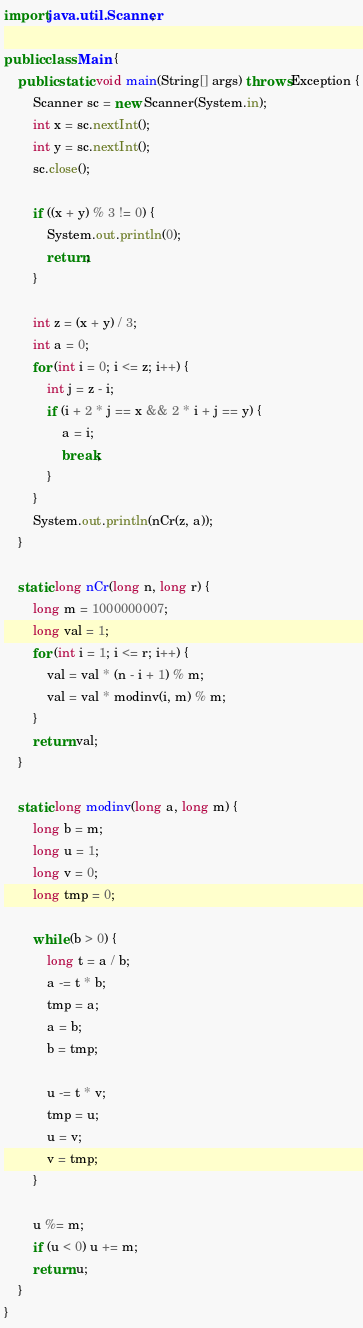<code> <loc_0><loc_0><loc_500><loc_500><_Java_>import java.util.Scanner;

public class Main {
	public static void main(String[] args) throws Exception {
		Scanner sc = new Scanner(System.in);
		int x = sc.nextInt();
		int y = sc.nextInt();
		sc.close();

		if ((x + y) % 3 != 0) {
			System.out.println(0);
			return;
		}

		int z = (x + y) / 3;
		int a = 0;
		for (int i = 0; i <= z; i++) {
			int j = z - i;
			if (i + 2 * j == x && 2 * i + j == y) {
				a = i;
				break;
			}
		}
		System.out.println(nCr(z, a));
	}

	static long nCr(long n, long r) {
		long m = 1000000007;
		long val = 1;
		for (int i = 1; i <= r; i++) {
			val = val * (n - i + 1) % m;
			val = val * modinv(i, m) % m;
		}
		return val;
	}

	static long modinv(long a, long m) {
		long b = m;
		long u = 1;
		long v = 0;
		long tmp = 0;

		while (b > 0) {
			long t = a / b;
			a -= t * b;
			tmp = a;
			a = b;
			b = tmp;

			u -= t * v;
			tmp = u;
			u = v;
			v = tmp;
		}

		u %= m;
		if (u < 0) u += m;
		return u;
	}
}
</code> 